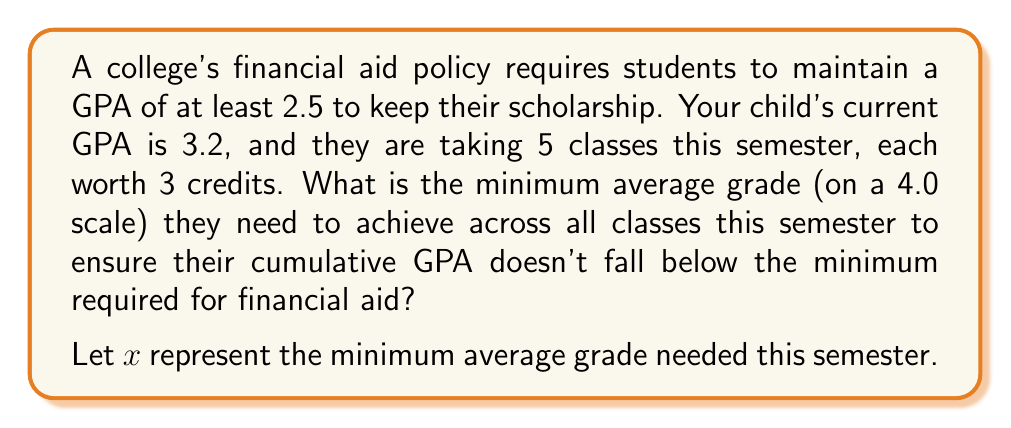Can you solve this math problem? Let's approach this step-by-step:

1) First, we need to understand how GPA is calculated. It's a weighted average of grade points and credits.

2) Your child's current GPA is 3.2. Let's assume they've completed 30 credits so far. So their total grade points are:

   $3.2 \times 30 = 96$ grade points

3) This semester, they're taking 5 classes, each worth 3 credits. Total new credits = $5 \times 3 = 15$ credits

4) After this semester, their total credits will be $30 + 15 = 45$ credits

5) To maintain the minimum 2.5 GPA, they need to have at least:

   $2.5 \times 45 = 112.5$ total grade points after this semester

6) Let $x$ be the average grade needed this semester. We can set up an inequality:

   $\frac{96 + 15x}{45} \geq 2.5$

7) Solve the inequality:

   $96 + 15x \geq 112.5$
   $15x \geq 16.5$
   $x \geq 1.1$

8) Therefore, your child needs to achieve an average grade of at least 1.1 across all classes this semester to maintain their scholarship.

9) Note: While this is mathematically correct, in practice, your child should aim for a higher GPA to ensure they comfortably meet the requirement and maintain a strong academic record.
Answer: $x \geq 1.1$ on a 4.0 scale 